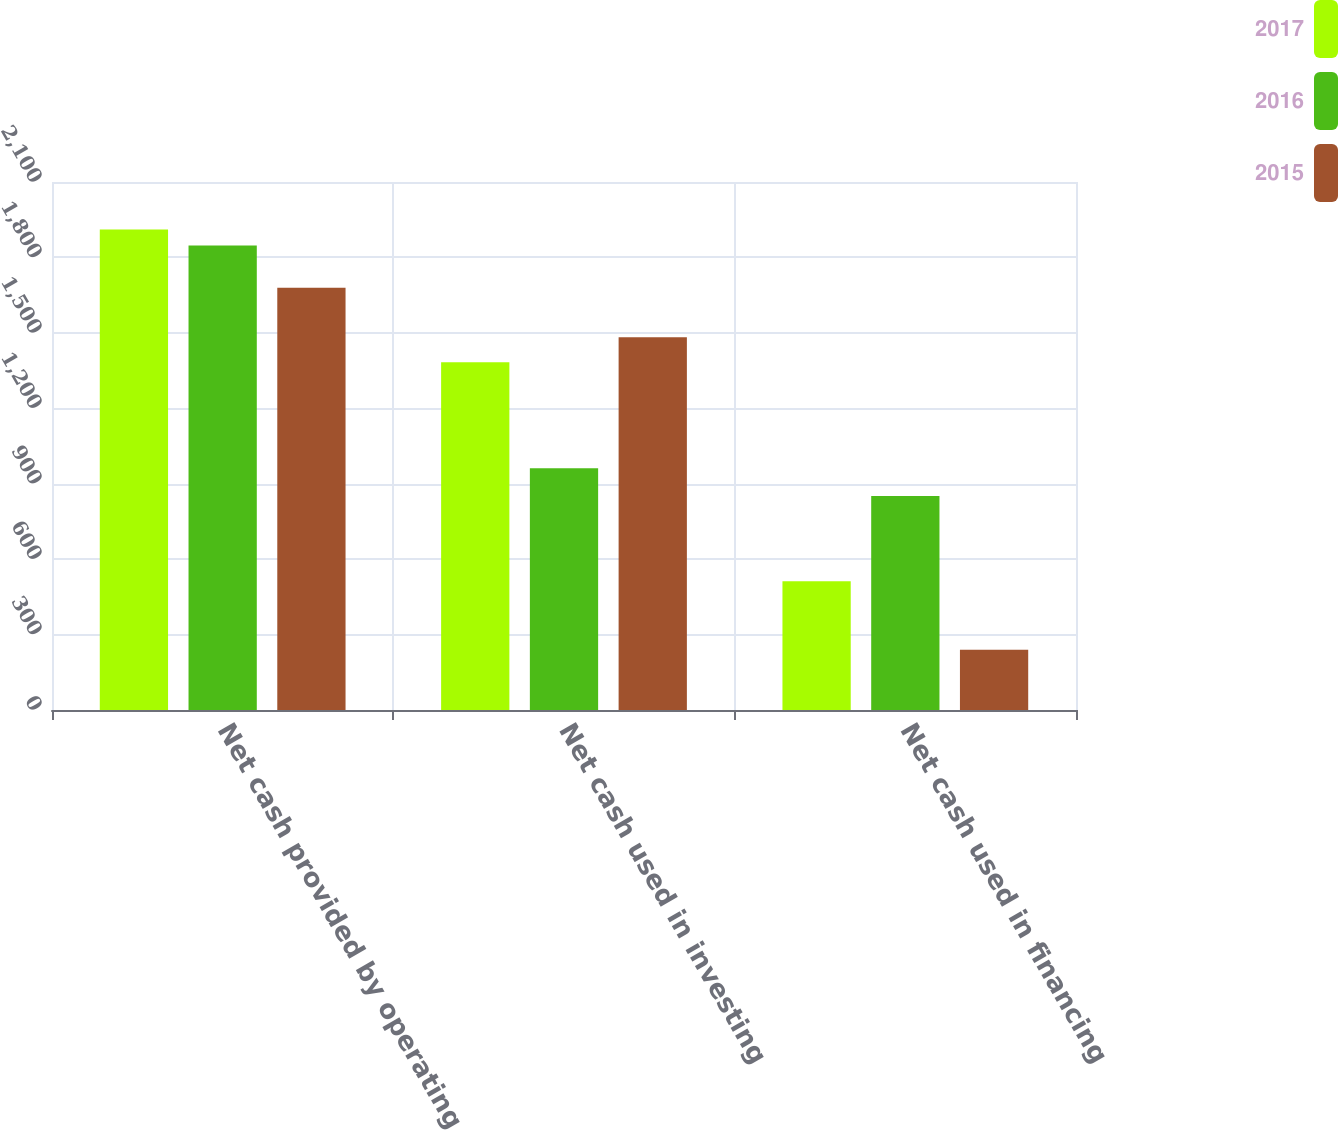<chart> <loc_0><loc_0><loc_500><loc_500><stacked_bar_chart><ecel><fcel>Net cash provided by operating<fcel>Net cash used in investing<fcel>Net cash used in financing<nl><fcel>2017<fcel>1910.7<fcel>1383.4<fcel>511.8<nl><fcel>2016<fcel>1847.8<fcel>961.2<fcel>851.2<nl><fcel>2015<fcel>1679.7<fcel>1482.8<fcel>239.7<nl></chart> 